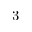<formula> <loc_0><loc_0><loc_500><loc_500>3</formula> 